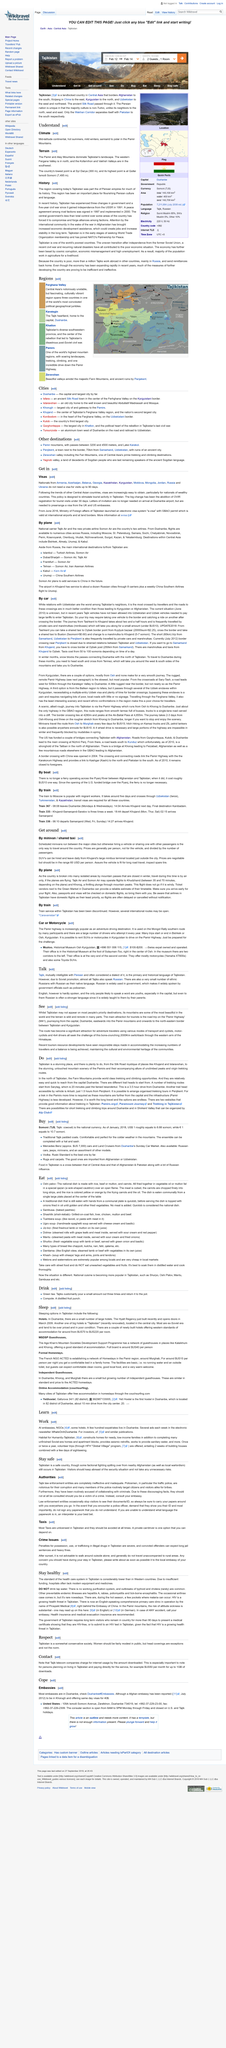Identify some key points in this picture. Nationals from Armenia, Azerbaijan, Belarus, Georgia, Kazakhstan, Kyrgyzstan, Moldova, Mongolia, Jordan, Russia and Ukraine can enter certain countries for visits up to 90 days without obtaining a visa. The Ministry of Foreign Affairs of Tajikistan launched the e-visa system, known as 'e-visa', in June 2016. Letters of invitation are no longer required at Dushanbe airport, but are still necessary to obtain a visa from the UK and US embassies in advance. 